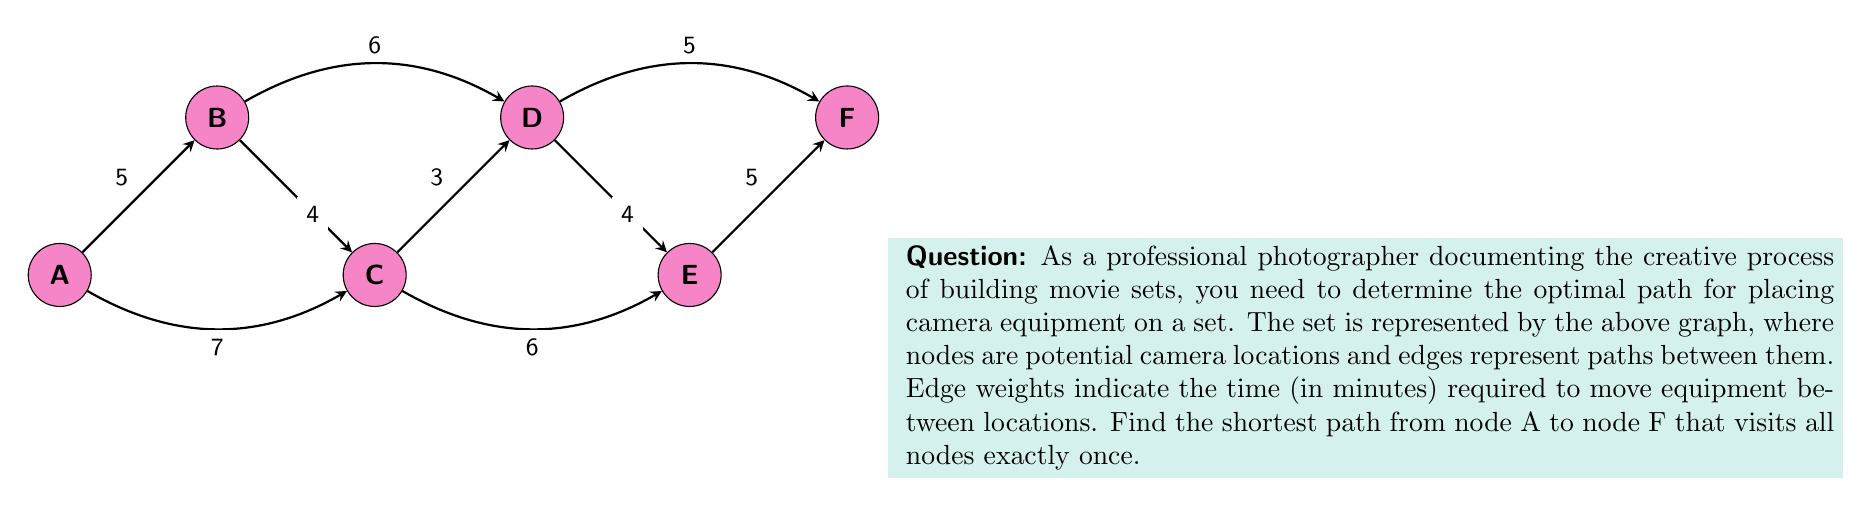Provide a solution to this math problem. To solve this problem, we need to find the Hamiltonian path with the lowest total weight from A to F. Let's approach this systematically:

1) First, list all possible paths from A to F that visit all nodes exactly once:
   - A-B-C-D-E-F
   - A-B-D-C-E-F
   - A-C-B-D-E-F
   - A-C-D-B-E-F
   - A-C-E-D-B-F

2) Now, calculate the total weight (time) for each path:

   A-B-C-D-E-F: 
   $5 + 4 + 3 + 4 + 5 = 21$ minutes

   A-B-D-C-E-F: 
   $5 + 6 + 3 + 6 + 5 = 25$ minutes

   A-C-B-D-E-F: 
   $7 + 4 + 6 + 4 + 5 = 26$ minutes

   A-C-D-B-E-F: 
   $7 + 3 + 6 + 5 + 5 = 26$ minutes

   A-C-E-D-B-F: 
   $7 + 6 + 4 + 6 + 5 = 28$ minutes

3) The path with the lowest total weight is A-B-C-D-E-F, taking 21 minutes.

This path allows you to efficiently place your camera equipment, visiting all required locations in the shortest amount of time.
Answer: A-B-C-D-E-F, 21 minutes 